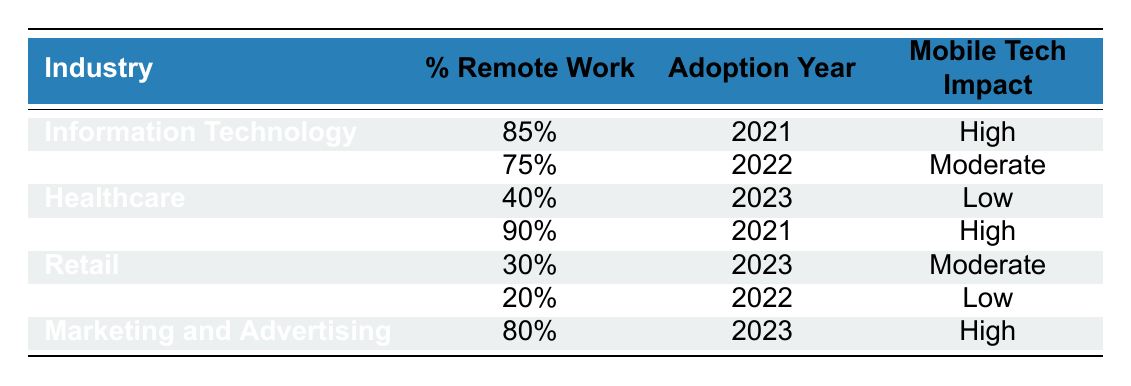What percentage of remote work did the Information Technology industry adopt? The table indicates that the Information Technology industry has a percentage of remote work at 85%.
Answer: 85% Which industry had the lowest percentage of remote work in 2022? According to the table, both Manufacturing and Finance had remote work adoption years in 2022, but Manufacturing had the lowest percentage of remote work at 20%.
Answer: Manufacturing Is the mobile technology impact for the Healthcare industry moderate? The table shows that the mobile technology impact for the Healthcare industry is categorized as Low, not moderate. Therefore, the statement is false.
Answer: No What industries had a high impact from mobile technology? From the table, both Information Technology, Education, and Marketing and Advertising have a high impact from mobile technology.
Answer: Information Technology, Education, Marketing and Advertising Calculate the average percentage of remote work for all the industries listed in the table. To calculate the average, sum the percentages: (85 + 75 + 40 + 90 + 30 + 20 + 80) = 420. There are 7 industries, so the average is 420 / 7 = 60.
Answer: 60 Which industry adopted remote work in 2023 with a percentage of 30%? The table states that the Retail industry adopted remote work in 2023 and has a percentage of 30%.
Answer: Retail Did the Education industry adopt remote work earlier than the Finance industry? The table shows that the Education industry adopted remote work in 2021 while the Finance industry adopted it in 2022. Therefore, the Education industry adopted remote work earlier.
Answer: Yes Which industry experienced a high impact from mobile technology but had a lower remote work percentage than Healthcare? The only industry with a high impact from mobile technology (Marketing and Advertising) and lower remote work percentage compared to Healthcare (40%) is none, as Marketing and Advertising had a higher remote work percentage of 80%.
Answer: None 